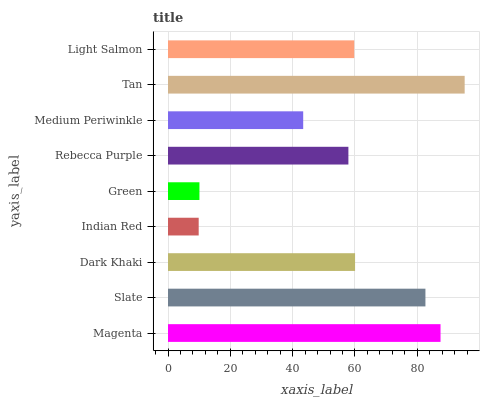Is Indian Red the minimum?
Answer yes or no. Yes. Is Tan the maximum?
Answer yes or no. Yes. Is Slate the minimum?
Answer yes or no. No. Is Slate the maximum?
Answer yes or no. No. Is Magenta greater than Slate?
Answer yes or no. Yes. Is Slate less than Magenta?
Answer yes or no. Yes. Is Slate greater than Magenta?
Answer yes or no. No. Is Magenta less than Slate?
Answer yes or no. No. Is Light Salmon the high median?
Answer yes or no. Yes. Is Light Salmon the low median?
Answer yes or no. Yes. Is Dark Khaki the high median?
Answer yes or no. No. Is Slate the low median?
Answer yes or no. No. 